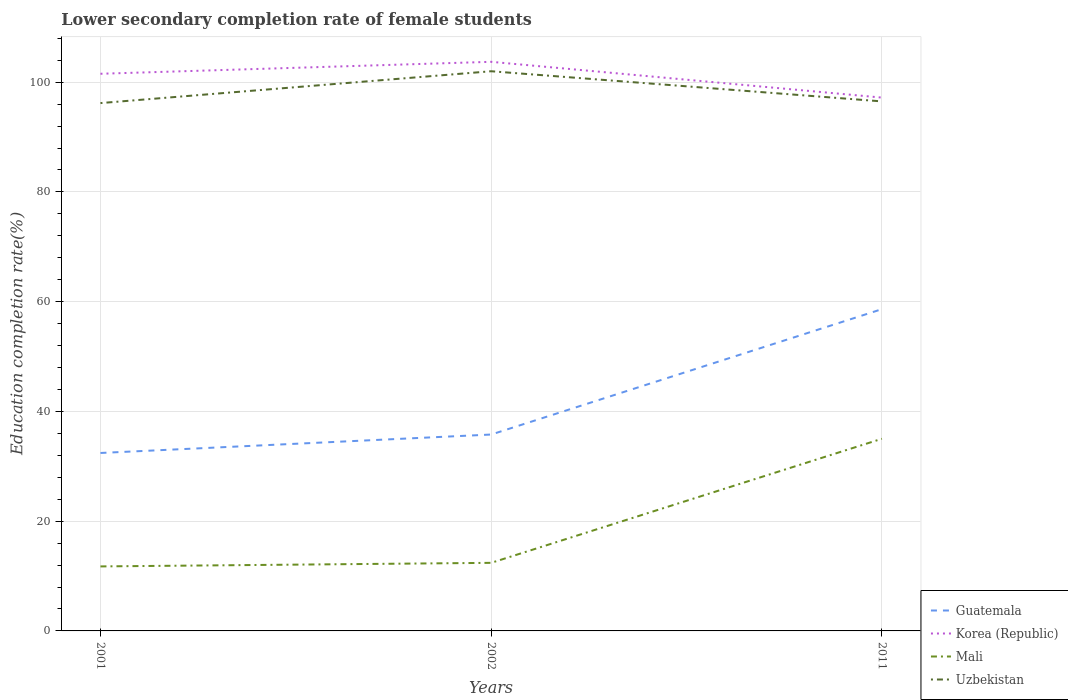Does the line corresponding to Mali intersect with the line corresponding to Uzbekistan?
Provide a short and direct response. No. Across all years, what is the maximum lower secondary completion rate of female students in Guatemala?
Your answer should be compact. 32.43. In which year was the lower secondary completion rate of female students in Uzbekistan maximum?
Offer a very short reply. 2001. What is the total lower secondary completion rate of female students in Korea (Republic) in the graph?
Offer a terse response. 6.52. What is the difference between the highest and the second highest lower secondary completion rate of female students in Guatemala?
Offer a terse response. 26.21. Is the lower secondary completion rate of female students in Mali strictly greater than the lower secondary completion rate of female students in Uzbekistan over the years?
Your response must be concise. Yes. How many lines are there?
Your answer should be compact. 4. What is the difference between two consecutive major ticks on the Y-axis?
Keep it short and to the point. 20. Does the graph contain grids?
Offer a terse response. Yes. Where does the legend appear in the graph?
Your response must be concise. Bottom right. What is the title of the graph?
Ensure brevity in your answer.  Lower secondary completion rate of female students. What is the label or title of the X-axis?
Your answer should be very brief. Years. What is the label or title of the Y-axis?
Give a very brief answer. Education completion rate(%). What is the Education completion rate(%) in Guatemala in 2001?
Keep it short and to the point. 32.43. What is the Education completion rate(%) of Korea (Republic) in 2001?
Your answer should be very brief. 101.54. What is the Education completion rate(%) in Mali in 2001?
Make the answer very short. 11.76. What is the Education completion rate(%) of Uzbekistan in 2001?
Your answer should be very brief. 96.2. What is the Education completion rate(%) of Guatemala in 2002?
Keep it short and to the point. 35.79. What is the Education completion rate(%) in Korea (Republic) in 2002?
Keep it short and to the point. 103.72. What is the Education completion rate(%) of Mali in 2002?
Provide a succinct answer. 12.41. What is the Education completion rate(%) of Uzbekistan in 2002?
Provide a short and direct response. 102. What is the Education completion rate(%) of Guatemala in 2011?
Offer a very short reply. 58.64. What is the Education completion rate(%) of Korea (Republic) in 2011?
Keep it short and to the point. 97.19. What is the Education completion rate(%) in Mali in 2011?
Provide a short and direct response. 35.02. What is the Education completion rate(%) in Uzbekistan in 2011?
Your response must be concise. 96.5. Across all years, what is the maximum Education completion rate(%) in Guatemala?
Ensure brevity in your answer.  58.64. Across all years, what is the maximum Education completion rate(%) in Korea (Republic)?
Ensure brevity in your answer.  103.72. Across all years, what is the maximum Education completion rate(%) of Mali?
Give a very brief answer. 35.02. Across all years, what is the maximum Education completion rate(%) in Uzbekistan?
Your response must be concise. 102. Across all years, what is the minimum Education completion rate(%) in Guatemala?
Keep it short and to the point. 32.43. Across all years, what is the minimum Education completion rate(%) of Korea (Republic)?
Your response must be concise. 97.19. Across all years, what is the minimum Education completion rate(%) of Mali?
Offer a terse response. 11.76. Across all years, what is the minimum Education completion rate(%) of Uzbekistan?
Provide a short and direct response. 96.2. What is the total Education completion rate(%) in Guatemala in the graph?
Give a very brief answer. 126.86. What is the total Education completion rate(%) in Korea (Republic) in the graph?
Provide a succinct answer. 302.45. What is the total Education completion rate(%) of Mali in the graph?
Give a very brief answer. 59.18. What is the total Education completion rate(%) of Uzbekistan in the graph?
Give a very brief answer. 294.69. What is the difference between the Education completion rate(%) in Guatemala in 2001 and that in 2002?
Give a very brief answer. -3.36. What is the difference between the Education completion rate(%) of Korea (Republic) in 2001 and that in 2002?
Keep it short and to the point. -2.18. What is the difference between the Education completion rate(%) of Mali in 2001 and that in 2002?
Your response must be concise. -0.65. What is the difference between the Education completion rate(%) in Uzbekistan in 2001 and that in 2002?
Your answer should be very brief. -5.8. What is the difference between the Education completion rate(%) in Guatemala in 2001 and that in 2011?
Make the answer very short. -26.21. What is the difference between the Education completion rate(%) in Korea (Republic) in 2001 and that in 2011?
Provide a short and direct response. 4.34. What is the difference between the Education completion rate(%) of Mali in 2001 and that in 2011?
Keep it short and to the point. -23.26. What is the difference between the Education completion rate(%) of Uzbekistan in 2001 and that in 2011?
Make the answer very short. -0.31. What is the difference between the Education completion rate(%) in Guatemala in 2002 and that in 2011?
Give a very brief answer. -22.85. What is the difference between the Education completion rate(%) of Korea (Republic) in 2002 and that in 2011?
Give a very brief answer. 6.52. What is the difference between the Education completion rate(%) in Mali in 2002 and that in 2011?
Your response must be concise. -22.61. What is the difference between the Education completion rate(%) of Uzbekistan in 2002 and that in 2011?
Offer a very short reply. 5.5. What is the difference between the Education completion rate(%) of Guatemala in 2001 and the Education completion rate(%) of Korea (Republic) in 2002?
Offer a terse response. -71.29. What is the difference between the Education completion rate(%) in Guatemala in 2001 and the Education completion rate(%) in Mali in 2002?
Your response must be concise. 20.02. What is the difference between the Education completion rate(%) of Guatemala in 2001 and the Education completion rate(%) of Uzbekistan in 2002?
Give a very brief answer. -69.57. What is the difference between the Education completion rate(%) of Korea (Republic) in 2001 and the Education completion rate(%) of Mali in 2002?
Your answer should be very brief. 89.13. What is the difference between the Education completion rate(%) in Korea (Republic) in 2001 and the Education completion rate(%) in Uzbekistan in 2002?
Offer a very short reply. -0.46. What is the difference between the Education completion rate(%) of Mali in 2001 and the Education completion rate(%) of Uzbekistan in 2002?
Your answer should be very brief. -90.24. What is the difference between the Education completion rate(%) of Guatemala in 2001 and the Education completion rate(%) of Korea (Republic) in 2011?
Ensure brevity in your answer.  -64.77. What is the difference between the Education completion rate(%) of Guatemala in 2001 and the Education completion rate(%) of Mali in 2011?
Provide a short and direct response. -2.59. What is the difference between the Education completion rate(%) in Guatemala in 2001 and the Education completion rate(%) in Uzbekistan in 2011?
Your response must be concise. -64.07. What is the difference between the Education completion rate(%) in Korea (Republic) in 2001 and the Education completion rate(%) in Mali in 2011?
Your response must be concise. 66.52. What is the difference between the Education completion rate(%) in Korea (Republic) in 2001 and the Education completion rate(%) in Uzbekistan in 2011?
Provide a short and direct response. 5.04. What is the difference between the Education completion rate(%) of Mali in 2001 and the Education completion rate(%) of Uzbekistan in 2011?
Your answer should be very brief. -84.75. What is the difference between the Education completion rate(%) of Guatemala in 2002 and the Education completion rate(%) of Korea (Republic) in 2011?
Keep it short and to the point. -61.4. What is the difference between the Education completion rate(%) in Guatemala in 2002 and the Education completion rate(%) in Mali in 2011?
Provide a short and direct response. 0.77. What is the difference between the Education completion rate(%) in Guatemala in 2002 and the Education completion rate(%) in Uzbekistan in 2011?
Ensure brevity in your answer.  -60.71. What is the difference between the Education completion rate(%) of Korea (Republic) in 2002 and the Education completion rate(%) of Mali in 2011?
Provide a short and direct response. 68.7. What is the difference between the Education completion rate(%) of Korea (Republic) in 2002 and the Education completion rate(%) of Uzbekistan in 2011?
Make the answer very short. 7.22. What is the difference between the Education completion rate(%) in Mali in 2002 and the Education completion rate(%) in Uzbekistan in 2011?
Offer a terse response. -84.09. What is the average Education completion rate(%) of Guatemala per year?
Your answer should be compact. 42.29. What is the average Education completion rate(%) in Korea (Republic) per year?
Offer a terse response. 100.82. What is the average Education completion rate(%) in Mali per year?
Keep it short and to the point. 19.73. What is the average Education completion rate(%) of Uzbekistan per year?
Make the answer very short. 98.23. In the year 2001, what is the difference between the Education completion rate(%) in Guatemala and Education completion rate(%) in Korea (Republic)?
Give a very brief answer. -69.11. In the year 2001, what is the difference between the Education completion rate(%) in Guatemala and Education completion rate(%) in Mali?
Offer a very short reply. 20.67. In the year 2001, what is the difference between the Education completion rate(%) in Guatemala and Education completion rate(%) in Uzbekistan?
Give a very brief answer. -63.77. In the year 2001, what is the difference between the Education completion rate(%) in Korea (Republic) and Education completion rate(%) in Mali?
Offer a terse response. 89.78. In the year 2001, what is the difference between the Education completion rate(%) of Korea (Republic) and Education completion rate(%) of Uzbekistan?
Your answer should be very brief. 5.34. In the year 2001, what is the difference between the Education completion rate(%) of Mali and Education completion rate(%) of Uzbekistan?
Provide a short and direct response. -84.44. In the year 2002, what is the difference between the Education completion rate(%) in Guatemala and Education completion rate(%) in Korea (Republic)?
Offer a very short reply. -67.93. In the year 2002, what is the difference between the Education completion rate(%) in Guatemala and Education completion rate(%) in Mali?
Your answer should be very brief. 23.38. In the year 2002, what is the difference between the Education completion rate(%) of Guatemala and Education completion rate(%) of Uzbekistan?
Make the answer very short. -66.21. In the year 2002, what is the difference between the Education completion rate(%) of Korea (Republic) and Education completion rate(%) of Mali?
Make the answer very short. 91.31. In the year 2002, what is the difference between the Education completion rate(%) of Korea (Republic) and Education completion rate(%) of Uzbekistan?
Provide a short and direct response. 1.72. In the year 2002, what is the difference between the Education completion rate(%) in Mali and Education completion rate(%) in Uzbekistan?
Provide a short and direct response. -89.59. In the year 2011, what is the difference between the Education completion rate(%) in Guatemala and Education completion rate(%) in Korea (Republic)?
Make the answer very short. -38.56. In the year 2011, what is the difference between the Education completion rate(%) of Guatemala and Education completion rate(%) of Mali?
Provide a succinct answer. 23.62. In the year 2011, what is the difference between the Education completion rate(%) of Guatemala and Education completion rate(%) of Uzbekistan?
Make the answer very short. -37.86. In the year 2011, what is the difference between the Education completion rate(%) of Korea (Republic) and Education completion rate(%) of Mali?
Your answer should be very brief. 62.18. In the year 2011, what is the difference between the Education completion rate(%) in Korea (Republic) and Education completion rate(%) in Uzbekistan?
Provide a short and direct response. 0.69. In the year 2011, what is the difference between the Education completion rate(%) in Mali and Education completion rate(%) in Uzbekistan?
Your response must be concise. -61.48. What is the ratio of the Education completion rate(%) of Guatemala in 2001 to that in 2002?
Give a very brief answer. 0.91. What is the ratio of the Education completion rate(%) of Mali in 2001 to that in 2002?
Offer a very short reply. 0.95. What is the ratio of the Education completion rate(%) of Uzbekistan in 2001 to that in 2002?
Offer a terse response. 0.94. What is the ratio of the Education completion rate(%) in Guatemala in 2001 to that in 2011?
Provide a succinct answer. 0.55. What is the ratio of the Education completion rate(%) in Korea (Republic) in 2001 to that in 2011?
Provide a short and direct response. 1.04. What is the ratio of the Education completion rate(%) in Mali in 2001 to that in 2011?
Provide a short and direct response. 0.34. What is the ratio of the Education completion rate(%) in Uzbekistan in 2001 to that in 2011?
Your answer should be compact. 1. What is the ratio of the Education completion rate(%) in Guatemala in 2002 to that in 2011?
Keep it short and to the point. 0.61. What is the ratio of the Education completion rate(%) of Korea (Republic) in 2002 to that in 2011?
Your response must be concise. 1.07. What is the ratio of the Education completion rate(%) in Mali in 2002 to that in 2011?
Your answer should be very brief. 0.35. What is the ratio of the Education completion rate(%) of Uzbekistan in 2002 to that in 2011?
Provide a short and direct response. 1.06. What is the difference between the highest and the second highest Education completion rate(%) of Guatemala?
Provide a short and direct response. 22.85. What is the difference between the highest and the second highest Education completion rate(%) of Korea (Republic)?
Make the answer very short. 2.18. What is the difference between the highest and the second highest Education completion rate(%) of Mali?
Keep it short and to the point. 22.61. What is the difference between the highest and the second highest Education completion rate(%) of Uzbekistan?
Offer a very short reply. 5.5. What is the difference between the highest and the lowest Education completion rate(%) of Guatemala?
Your answer should be compact. 26.21. What is the difference between the highest and the lowest Education completion rate(%) in Korea (Republic)?
Offer a terse response. 6.52. What is the difference between the highest and the lowest Education completion rate(%) in Mali?
Ensure brevity in your answer.  23.26. What is the difference between the highest and the lowest Education completion rate(%) of Uzbekistan?
Provide a succinct answer. 5.8. 